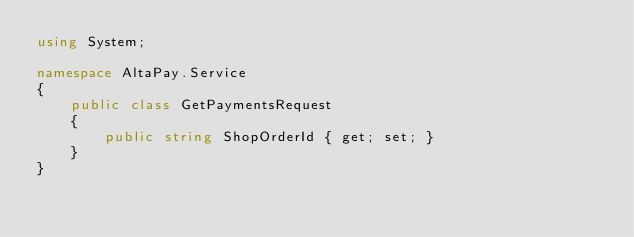Convert code to text. <code><loc_0><loc_0><loc_500><loc_500><_C#_>using System;

namespace AltaPay.Service
{
	public class GetPaymentsRequest
	{
		public string ShopOrderId { get; set; }
	}
}

</code> 